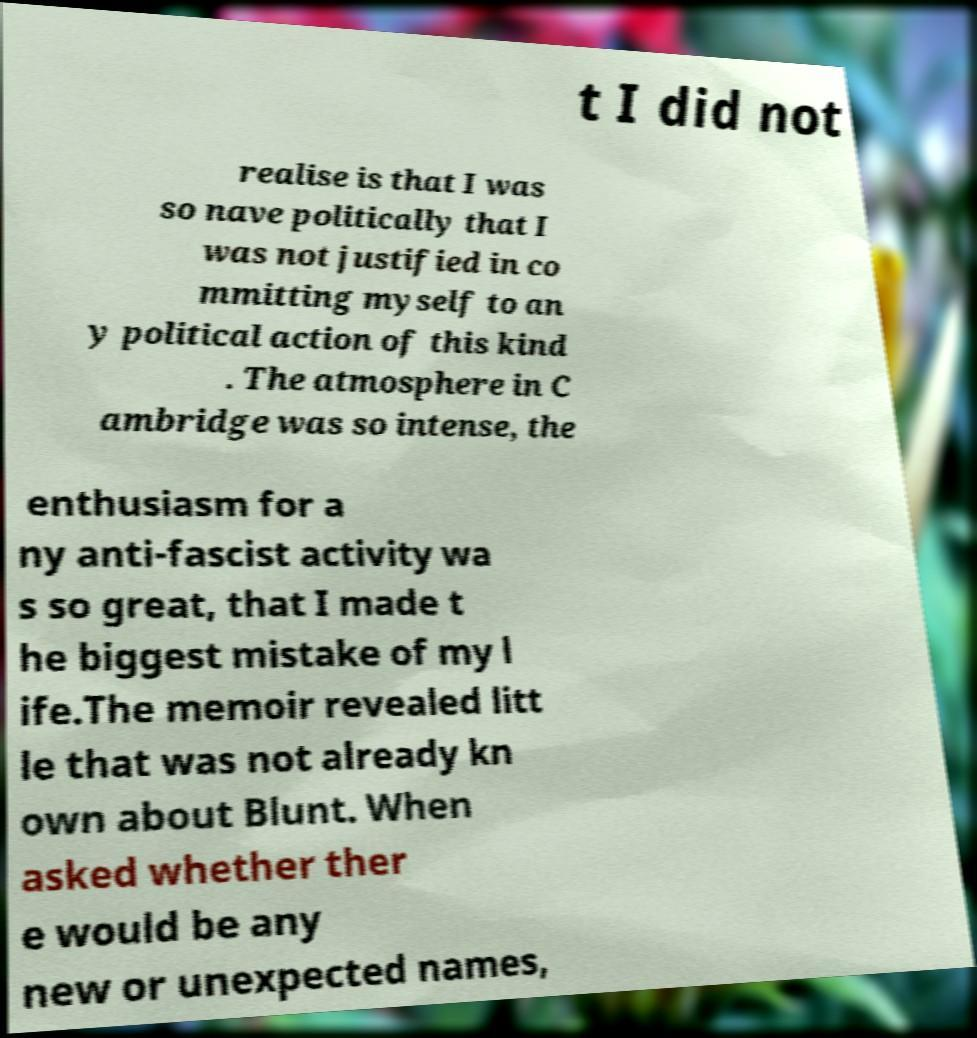What messages or text are displayed in this image? I need them in a readable, typed format. t I did not realise is that I was so nave politically that I was not justified in co mmitting myself to an y political action of this kind . The atmosphere in C ambridge was so intense, the enthusiasm for a ny anti-fascist activity wa s so great, that I made t he biggest mistake of my l ife.The memoir revealed litt le that was not already kn own about Blunt. When asked whether ther e would be any new or unexpected names, 